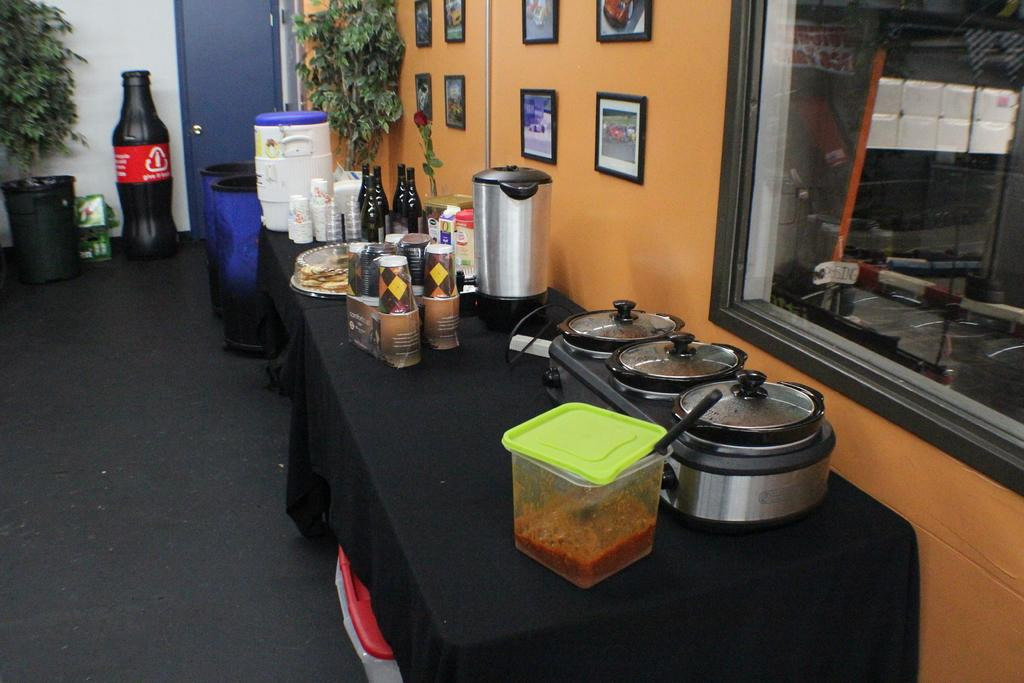<image>
Provide a brief description of the given image. Room with a trashcan and a box of 7up next to it. 